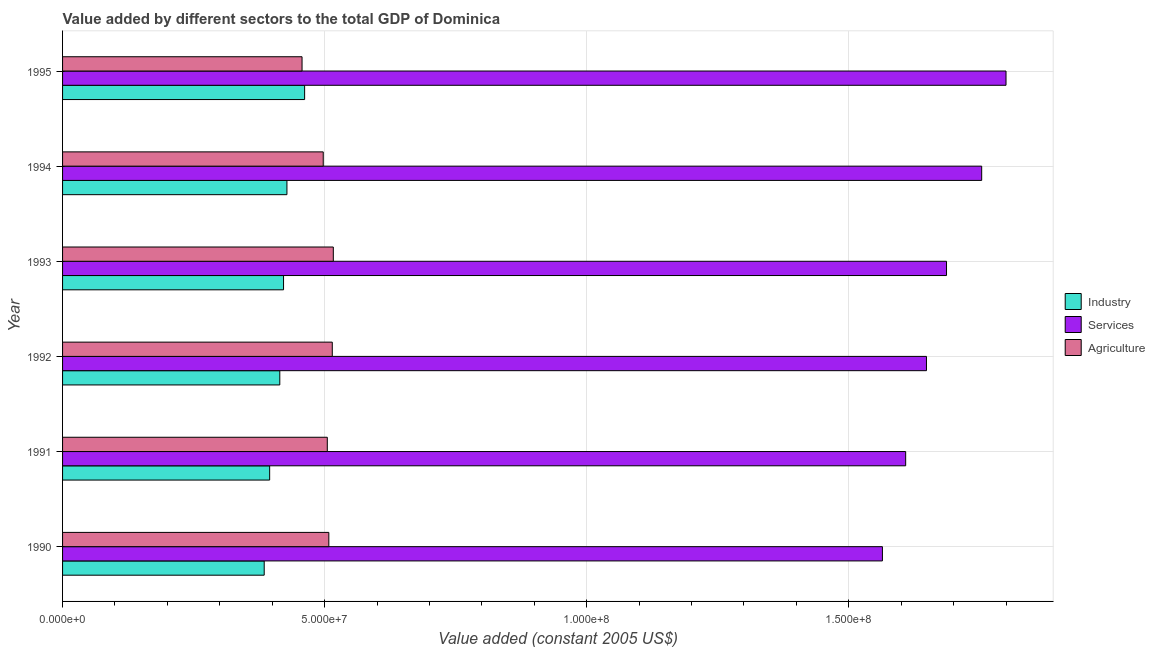How many different coloured bars are there?
Your response must be concise. 3. How many groups of bars are there?
Your answer should be very brief. 6. Are the number of bars per tick equal to the number of legend labels?
Your answer should be very brief. Yes. Are the number of bars on each tick of the Y-axis equal?
Keep it short and to the point. Yes. In how many cases, is the number of bars for a given year not equal to the number of legend labels?
Offer a very short reply. 0. What is the value added by services in 1993?
Provide a short and direct response. 1.69e+08. Across all years, what is the maximum value added by industrial sector?
Offer a terse response. 4.62e+07. Across all years, what is the minimum value added by industrial sector?
Keep it short and to the point. 3.85e+07. In which year was the value added by agricultural sector maximum?
Provide a short and direct response. 1993. In which year was the value added by industrial sector minimum?
Provide a succinct answer. 1990. What is the total value added by industrial sector in the graph?
Provide a short and direct response. 2.51e+08. What is the difference between the value added by industrial sector in 1990 and that in 1995?
Provide a short and direct response. -7.71e+06. What is the difference between the value added by industrial sector in 1992 and the value added by agricultural sector in 1993?
Keep it short and to the point. -1.02e+07. What is the average value added by services per year?
Ensure brevity in your answer.  1.68e+08. In the year 1995, what is the difference between the value added by services and value added by industrial sector?
Offer a terse response. 1.34e+08. In how many years, is the value added by services greater than 40000000 US$?
Your response must be concise. 6. What is the ratio of the value added by industrial sector in 1991 to that in 1994?
Offer a terse response. 0.92. Is the value added by agricultural sector in 1993 less than that in 1994?
Offer a terse response. No. Is the difference between the value added by services in 1993 and 1994 greater than the difference between the value added by agricultural sector in 1993 and 1994?
Your response must be concise. No. What is the difference between the highest and the second highest value added by services?
Your answer should be very brief. 4.64e+06. What is the difference between the highest and the lowest value added by agricultural sector?
Make the answer very short. 5.96e+06. In how many years, is the value added by services greater than the average value added by services taken over all years?
Offer a terse response. 3. Is the sum of the value added by services in 1992 and 1994 greater than the maximum value added by agricultural sector across all years?
Provide a short and direct response. Yes. What does the 3rd bar from the top in 1990 represents?
Offer a terse response. Industry. What does the 3rd bar from the bottom in 1993 represents?
Offer a terse response. Agriculture. How many bars are there?
Provide a succinct answer. 18. Does the graph contain any zero values?
Keep it short and to the point. No. Where does the legend appear in the graph?
Your answer should be compact. Center right. How are the legend labels stacked?
Your answer should be compact. Vertical. What is the title of the graph?
Offer a very short reply. Value added by different sectors to the total GDP of Dominica. Does "Ages 15-64" appear as one of the legend labels in the graph?
Give a very brief answer. No. What is the label or title of the X-axis?
Give a very brief answer. Value added (constant 2005 US$). What is the label or title of the Y-axis?
Ensure brevity in your answer.  Year. What is the Value added (constant 2005 US$) of Industry in 1990?
Offer a terse response. 3.85e+07. What is the Value added (constant 2005 US$) of Services in 1990?
Make the answer very short. 1.56e+08. What is the Value added (constant 2005 US$) of Agriculture in 1990?
Offer a terse response. 5.08e+07. What is the Value added (constant 2005 US$) in Industry in 1991?
Keep it short and to the point. 3.95e+07. What is the Value added (constant 2005 US$) in Services in 1991?
Offer a very short reply. 1.61e+08. What is the Value added (constant 2005 US$) of Agriculture in 1991?
Keep it short and to the point. 5.05e+07. What is the Value added (constant 2005 US$) in Industry in 1992?
Ensure brevity in your answer.  4.14e+07. What is the Value added (constant 2005 US$) in Services in 1992?
Offer a very short reply. 1.65e+08. What is the Value added (constant 2005 US$) of Agriculture in 1992?
Offer a very short reply. 5.15e+07. What is the Value added (constant 2005 US$) in Industry in 1993?
Give a very brief answer. 4.22e+07. What is the Value added (constant 2005 US$) of Services in 1993?
Provide a short and direct response. 1.69e+08. What is the Value added (constant 2005 US$) of Agriculture in 1993?
Offer a terse response. 5.17e+07. What is the Value added (constant 2005 US$) of Industry in 1994?
Give a very brief answer. 4.28e+07. What is the Value added (constant 2005 US$) of Services in 1994?
Provide a short and direct response. 1.75e+08. What is the Value added (constant 2005 US$) in Agriculture in 1994?
Make the answer very short. 4.97e+07. What is the Value added (constant 2005 US$) in Industry in 1995?
Make the answer very short. 4.62e+07. What is the Value added (constant 2005 US$) in Services in 1995?
Make the answer very short. 1.80e+08. What is the Value added (constant 2005 US$) of Agriculture in 1995?
Provide a short and direct response. 4.57e+07. Across all years, what is the maximum Value added (constant 2005 US$) in Industry?
Keep it short and to the point. 4.62e+07. Across all years, what is the maximum Value added (constant 2005 US$) in Services?
Your response must be concise. 1.80e+08. Across all years, what is the maximum Value added (constant 2005 US$) of Agriculture?
Provide a succinct answer. 5.17e+07. Across all years, what is the minimum Value added (constant 2005 US$) in Industry?
Your response must be concise. 3.85e+07. Across all years, what is the minimum Value added (constant 2005 US$) of Services?
Offer a very short reply. 1.56e+08. Across all years, what is the minimum Value added (constant 2005 US$) of Agriculture?
Ensure brevity in your answer.  4.57e+07. What is the total Value added (constant 2005 US$) of Industry in the graph?
Your response must be concise. 2.51e+08. What is the total Value added (constant 2005 US$) in Services in the graph?
Your answer should be compact. 1.01e+09. What is the total Value added (constant 2005 US$) of Agriculture in the graph?
Provide a succinct answer. 3.00e+08. What is the difference between the Value added (constant 2005 US$) in Industry in 1990 and that in 1991?
Offer a terse response. -1.04e+06. What is the difference between the Value added (constant 2005 US$) in Services in 1990 and that in 1991?
Keep it short and to the point. -4.44e+06. What is the difference between the Value added (constant 2005 US$) in Agriculture in 1990 and that in 1991?
Provide a succinct answer. 2.91e+05. What is the difference between the Value added (constant 2005 US$) in Industry in 1990 and that in 1992?
Offer a terse response. -2.97e+06. What is the difference between the Value added (constant 2005 US$) in Services in 1990 and that in 1992?
Make the answer very short. -8.40e+06. What is the difference between the Value added (constant 2005 US$) of Agriculture in 1990 and that in 1992?
Offer a terse response. -6.59e+05. What is the difference between the Value added (constant 2005 US$) in Industry in 1990 and that in 1993?
Your answer should be very brief. -3.69e+06. What is the difference between the Value added (constant 2005 US$) of Services in 1990 and that in 1993?
Keep it short and to the point. -1.22e+07. What is the difference between the Value added (constant 2005 US$) of Agriculture in 1990 and that in 1993?
Offer a very short reply. -8.57e+05. What is the difference between the Value added (constant 2005 US$) of Industry in 1990 and that in 1994?
Your response must be concise. -4.34e+06. What is the difference between the Value added (constant 2005 US$) in Services in 1990 and that in 1994?
Your response must be concise. -1.89e+07. What is the difference between the Value added (constant 2005 US$) in Agriculture in 1990 and that in 1994?
Make the answer very short. 1.07e+06. What is the difference between the Value added (constant 2005 US$) of Industry in 1990 and that in 1995?
Your answer should be very brief. -7.71e+06. What is the difference between the Value added (constant 2005 US$) of Services in 1990 and that in 1995?
Your answer should be very brief. -2.36e+07. What is the difference between the Value added (constant 2005 US$) of Agriculture in 1990 and that in 1995?
Offer a very short reply. 5.11e+06. What is the difference between the Value added (constant 2005 US$) in Industry in 1991 and that in 1992?
Offer a very short reply. -1.93e+06. What is the difference between the Value added (constant 2005 US$) in Services in 1991 and that in 1992?
Keep it short and to the point. -3.97e+06. What is the difference between the Value added (constant 2005 US$) in Agriculture in 1991 and that in 1992?
Your answer should be compact. -9.50e+05. What is the difference between the Value added (constant 2005 US$) of Industry in 1991 and that in 1993?
Offer a terse response. -2.65e+06. What is the difference between the Value added (constant 2005 US$) in Services in 1991 and that in 1993?
Provide a succinct answer. -7.79e+06. What is the difference between the Value added (constant 2005 US$) of Agriculture in 1991 and that in 1993?
Your answer should be very brief. -1.15e+06. What is the difference between the Value added (constant 2005 US$) of Industry in 1991 and that in 1994?
Your answer should be compact. -3.30e+06. What is the difference between the Value added (constant 2005 US$) of Services in 1991 and that in 1994?
Offer a terse response. -1.45e+07. What is the difference between the Value added (constant 2005 US$) in Agriculture in 1991 and that in 1994?
Your response must be concise. 7.74e+05. What is the difference between the Value added (constant 2005 US$) in Industry in 1991 and that in 1995?
Your answer should be compact. -6.67e+06. What is the difference between the Value added (constant 2005 US$) of Services in 1991 and that in 1995?
Your response must be concise. -1.91e+07. What is the difference between the Value added (constant 2005 US$) in Agriculture in 1991 and that in 1995?
Keep it short and to the point. 4.82e+06. What is the difference between the Value added (constant 2005 US$) in Industry in 1992 and that in 1993?
Provide a succinct answer. -7.15e+05. What is the difference between the Value added (constant 2005 US$) in Services in 1992 and that in 1993?
Make the answer very short. -3.82e+06. What is the difference between the Value added (constant 2005 US$) in Agriculture in 1992 and that in 1993?
Offer a very short reply. -1.98e+05. What is the difference between the Value added (constant 2005 US$) in Industry in 1992 and that in 1994?
Give a very brief answer. -1.36e+06. What is the difference between the Value added (constant 2005 US$) in Services in 1992 and that in 1994?
Offer a very short reply. -1.05e+07. What is the difference between the Value added (constant 2005 US$) in Agriculture in 1992 and that in 1994?
Ensure brevity in your answer.  1.72e+06. What is the difference between the Value added (constant 2005 US$) in Industry in 1992 and that in 1995?
Your response must be concise. -4.74e+06. What is the difference between the Value added (constant 2005 US$) in Services in 1992 and that in 1995?
Provide a short and direct response. -1.52e+07. What is the difference between the Value added (constant 2005 US$) in Agriculture in 1992 and that in 1995?
Give a very brief answer. 5.77e+06. What is the difference between the Value added (constant 2005 US$) in Industry in 1993 and that in 1994?
Keep it short and to the point. -6.48e+05. What is the difference between the Value added (constant 2005 US$) of Services in 1993 and that in 1994?
Provide a short and direct response. -6.71e+06. What is the difference between the Value added (constant 2005 US$) of Agriculture in 1993 and that in 1994?
Make the answer very short. 1.92e+06. What is the difference between the Value added (constant 2005 US$) of Industry in 1993 and that in 1995?
Offer a very short reply. -4.02e+06. What is the difference between the Value added (constant 2005 US$) of Services in 1993 and that in 1995?
Make the answer very short. -1.14e+07. What is the difference between the Value added (constant 2005 US$) in Agriculture in 1993 and that in 1995?
Your response must be concise. 5.96e+06. What is the difference between the Value added (constant 2005 US$) in Industry in 1994 and that in 1995?
Offer a very short reply. -3.37e+06. What is the difference between the Value added (constant 2005 US$) of Services in 1994 and that in 1995?
Your response must be concise. -4.64e+06. What is the difference between the Value added (constant 2005 US$) in Agriculture in 1994 and that in 1995?
Your answer should be very brief. 4.04e+06. What is the difference between the Value added (constant 2005 US$) in Industry in 1990 and the Value added (constant 2005 US$) in Services in 1991?
Ensure brevity in your answer.  -1.22e+08. What is the difference between the Value added (constant 2005 US$) in Industry in 1990 and the Value added (constant 2005 US$) in Agriculture in 1991?
Your response must be concise. -1.20e+07. What is the difference between the Value added (constant 2005 US$) of Services in 1990 and the Value added (constant 2005 US$) of Agriculture in 1991?
Keep it short and to the point. 1.06e+08. What is the difference between the Value added (constant 2005 US$) in Industry in 1990 and the Value added (constant 2005 US$) in Services in 1992?
Your answer should be compact. -1.26e+08. What is the difference between the Value added (constant 2005 US$) in Industry in 1990 and the Value added (constant 2005 US$) in Agriculture in 1992?
Keep it short and to the point. -1.30e+07. What is the difference between the Value added (constant 2005 US$) in Services in 1990 and the Value added (constant 2005 US$) in Agriculture in 1992?
Keep it short and to the point. 1.05e+08. What is the difference between the Value added (constant 2005 US$) in Industry in 1990 and the Value added (constant 2005 US$) in Services in 1993?
Offer a terse response. -1.30e+08. What is the difference between the Value added (constant 2005 US$) in Industry in 1990 and the Value added (constant 2005 US$) in Agriculture in 1993?
Make the answer very short. -1.32e+07. What is the difference between the Value added (constant 2005 US$) of Services in 1990 and the Value added (constant 2005 US$) of Agriculture in 1993?
Provide a succinct answer. 1.05e+08. What is the difference between the Value added (constant 2005 US$) in Industry in 1990 and the Value added (constant 2005 US$) in Services in 1994?
Make the answer very short. -1.37e+08. What is the difference between the Value added (constant 2005 US$) of Industry in 1990 and the Value added (constant 2005 US$) of Agriculture in 1994?
Give a very brief answer. -1.13e+07. What is the difference between the Value added (constant 2005 US$) in Services in 1990 and the Value added (constant 2005 US$) in Agriculture in 1994?
Keep it short and to the point. 1.07e+08. What is the difference between the Value added (constant 2005 US$) in Industry in 1990 and the Value added (constant 2005 US$) in Services in 1995?
Your response must be concise. -1.42e+08. What is the difference between the Value added (constant 2005 US$) in Industry in 1990 and the Value added (constant 2005 US$) in Agriculture in 1995?
Ensure brevity in your answer.  -7.22e+06. What is the difference between the Value added (constant 2005 US$) of Services in 1990 and the Value added (constant 2005 US$) of Agriculture in 1995?
Your answer should be compact. 1.11e+08. What is the difference between the Value added (constant 2005 US$) of Industry in 1991 and the Value added (constant 2005 US$) of Services in 1992?
Your response must be concise. -1.25e+08. What is the difference between the Value added (constant 2005 US$) in Industry in 1991 and the Value added (constant 2005 US$) in Agriculture in 1992?
Make the answer very short. -1.19e+07. What is the difference between the Value added (constant 2005 US$) of Services in 1991 and the Value added (constant 2005 US$) of Agriculture in 1992?
Your response must be concise. 1.09e+08. What is the difference between the Value added (constant 2005 US$) of Industry in 1991 and the Value added (constant 2005 US$) of Services in 1993?
Keep it short and to the point. -1.29e+08. What is the difference between the Value added (constant 2005 US$) of Industry in 1991 and the Value added (constant 2005 US$) of Agriculture in 1993?
Your response must be concise. -1.21e+07. What is the difference between the Value added (constant 2005 US$) in Services in 1991 and the Value added (constant 2005 US$) in Agriculture in 1993?
Provide a succinct answer. 1.09e+08. What is the difference between the Value added (constant 2005 US$) in Industry in 1991 and the Value added (constant 2005 US$) in Services in 1994?
Give a very brief answer. -1.36e+08. What is the difference between the Value added (constant 2005 US$) in Industry in 1991 and the Value added (constant 2005 US$) in Agriculture in 1994?
Your answer should be very brief. -1.02e+07. What is the difference between the Value added (constant 2005 US$) in Services in 1991 and the Value added (constant 2005 US$) in Agriculture in 1994?
Give a very brief answer. 1.11e+08. What is the difference between the Value added (constant 2005 US$) in Industry in 1991 and the Value added (constant 2005 US$) in Services in 1995?
Offer a terse response. -1.40e+08. What is the difference between the Value added (constant 2005 US$) of Industry in 1991 and the Value added (constant 2005 US$) of Agriculture in 1995?
Offer a terse response. -6.18e+06. What is the difference between the Value added (constant 2005 US$) in Services in 1991 and the Value added (constant 2005 US$) in Agriculture in 1995?
Ensure brevity in your answer.  1.15e+08. What is the difference between the Value added (constant 2005 US$) in Industry in 1992 and the Value added (constant 2005 US$) in Services in 1993?
Offer a very short reply. -1.27e+08. What is the difference between the Value added (constant 2005 US$) in Industry in 1992 and the Value added (constant 2005 US$) in Agriculture in 1993?
Keep it short and to the point. -1.02e+07. What is the difference between the Value added (constant 2005 US$) in Services in 1992 and the Value added (constant 2005 US$) in Agriculture in 1993?
Your answer should be compact. 1.13e+08. What is the difference between the Value added (constant 2005 US$) of Industry in 1992 and the Value added (constant 2005 US$) of Services in 1994?
Offer a terse response. -1.34e+08. What is the difference between the Value added (constant 2005 US$) of Industry in 1992 and the Value added (constant 2005 US$) of Agriculture in 1994?
Your answer should be very brief. -8.29e+06. What is the difference between the Value added (constant 2005 US$) of Services in 1992 and the Value added (constant 2005 US$) of Agriculture in 1994?
Give a very brief answer. 1.15e+08. What is the difference between the Value added (constant 2005 US$) of Industry in 1992 and the Value added (constant 2005 US$) of Services in 1995?
Provide a short and direct response. -1.39e+08. What is the difference between the Value added (constant 2005 US$) of Industry in 1992 and the Value added (constant 2005 US$) of Agriculture in 1995?
Offer a very short reply. -4.25e+06. What is the difference between the Value added (constant 2005 US$) of Services in 1992 and the Value added (constant 2005 US$) of Agriculture in 1995?
Your response must be concise. 1.19e+08. What is the difference between the Value added (constant 2005 US$) in Industry in 1993 and the Value added (constant 2005 US$) in Services in 1994?
Your answer should be compact. -1.33e+08. What is the difference between the Value added (constant 2005 US$) of Industry in 1993 and the Value added (constant 2005 US$) of Agriculture in 1994?
Your response must be concise. -7.57e+06. What is the difference between the Value added (constant 2005 US$) in Services in 1993 and the Value added (constant 2005 US$) in Agriculture in 1994?
Give a very brief answer. 1.19e+08. What is the difference between the Value added (constant 2005 US$) in Industry in 1993 and the Value added (constant 2005 US$) in Services in 1995?
Offer a very short reply. -1.38e+08. What is the difference between the Value added (constant 2005 US$) in Industry in 1993 and the Value added (constant 2005 US$) in Agriculture in 1995?
Your answer should be compact. -3.53e+06. What is the difference between the Value added (constant 2005 US$) in Services in 1993 and the Value added (constant 2005 US$) in Agriculture in 1995?
Offer a terse response. 1.23e+08. What is the difference between the Value added (constant 2005 US$) in Industry in 1994 and the Value added (constant 2005 US$) in Services in 1995?
Offer a very short reply. -1.37e+08. What is the difference between the Value added (constant 2005 US$) in Industry in 1994 and the Value added (constant 2005 US$) in Agriculture in 1995?
Offer a terse response. -2.88e+06. What is the difference between the Value added (constant 2005 US$) of Services in 1994 and the Value added (constant 2005 US$) of Agriculture in 1995?
Offer a terse response. 1.30e+08. What is the average Value added (constant 2005 US$) in Industry per year?
Your response must be concise. 4.18e+07. What is the average Value added (constant 2005 US$) in Services per year?
Give a very brief answer. 1.68e+08. What is the average Value added (constant 2005 US$) of Agriculture per year?
Offer a very short reply. 5.00e+07. In the year 1990, what is the difference between the Value added (constant 2005 US$) in Industry and Value added (constant 2005 US$) in Services?
Ensure brevity in your answer.  -1.18e+08. In the year 1990, what is the difference between the Value added (constant 2005 US$) of Industry and Value added (constant 2005 US$) of Agriculture?
Your answer should be compact. -1.23e+07. In the year 1990, what is the difference between the Value added (constant 2005 US$) in Services and Value added (constant 2005 US$) in Agriculture?
Offer a very short reply. 1.06e+08. In the year 1991, what is the difference between the Value added (constant 2005 US$) in Industry and Value added (constant 2005 US$) in Services?
Offer a very short reply. -1.21e+08. In the year 1991, what is the difference between the Value added (constant 2005 US$) of Industry and Value added (constant 2005 US$) of Agriculture?
Keep it short and to the point. -1.10e+07. In the year 1991, what is the difference between the Value added (constant 2005 US$) of Services and Value added (constant 2005 US$) of Agriculture?
Give a very brief answer. 1.10e+08. In the year 1992, what is the difference between the Value added (constant 2005 US$) of Industry and Value added (constant 2005 US$) of Services?
Provide a succinct answer. -1.23e+08. In the year 1992, what is the difference between the Value added (constant 2005 US$) in Industry and Value added (constant 2005 US$) in Agriculture?
Offer a terse response. -1.00e+07. In the year 1992, what is the difference between the Value added (constant 2005 US$) in Services and Value added (constant 2005 US$) in Agriculture?
Provide a succinct answer. 1.13e+08. In the year 1993, what is the difference between the Value added (constant 2005 US$) in Industry and Value added (constant 2005 US$) in Services?
Make the answer very short. -1.26e+08. In the year 1993, what is the difference between the Value added (constant 2005 US$) in Industry and Value added (constant 2005 US$) in Agriculture?
Offer a very short reply. -9.50e+06. In the year 1993, what is the difference between the Value added (constant 2005 US$) of Services and Value added (constant 2005 US$) of Agriculture?
Offer a terse response. 1.17e+08. In the year 1994, what is the difference between the Value added (constant 2005 US$) in Industry and Value added (constant 2005 US$) in Services?
Give a very brief answer. -1.33e+08. In the year 1994, what is the difference between the Value added (constant 2005 US$) of Industry and Value added (constant 2005 US$) of Agriculture?
Offer a terse response. -6.93e+06. In the year 1994, what is the difference between the Value added (constant 2005 US$) in Services and Value added (constant 2005 US$) in Agriculture?
Ensure brevity in your answer.  1.26e+08. In the year 1995, what is the difference between the Value added (constant 2005 US$) of Industry and Value added (constant 2005 US$) of Services?
Provide a succinct answer. -1.34e+08. In the year 1995, what is the difference between the Value added (constant 2005 US$) of Industry and Value added (constant 2005 US$) of Agriculture?
Your answer should be compact. 4.92e+05. In the year 1995, what is the difference between the Value added (constant 2005 US$) of Services and Value added (constant 2005 US$) of Agriculture?
Offer a very short reply. 1.34e+08. What is the ratio of the Value added (constant 2005 US$) of Industry in 1990 to that in 1991?
Give a very brief answer. 0.97. What is the ratio of the Value added (constant 2005 US$) in Services in 1990 to that in 1991?
Your response must be concise. 0.97. What is the ratio of the Value added (constant 2005 US$) in Industry in 1990 to that in 1992?
Provide a succinct answer. 0.93. What is the ratio of the Value added (constant 2005 US$) of Services in 1990 to that in 1992?
Provide a short and direct response. 0.95. What is the ratio of the Value added (constant 2005 US$) in Agriculture in 1990 to that in 1992?
Give a very brief answer. 0.99. What is the ratio of the Value added (constant 2005 US$) of Industry in 1990 to that in 1993?
Offer a terse response. 0.91. What is the ratio of the Value added (constant 2005 US$) in Services in 1990 to that in 1993?
Provide a short and direct response. 0.93. What is the ratio of the Value added (constant 2005 US$) of Agriculture in 1990 to that in 1993?
Make the answer very short. 0.98. What is the ratio of the Value added (constant 2005 US$) in Industry in 1990 to that in 1994?
Give a very brief answer. 0.9. What is the ratio of the Value added (constant 2005 US$) in Services in 1990 to that in 1994?
Ensure brevity in your answer.  0.89. What is the ratio of the Value added (constant 2005 US$) in Agriculture in 1990 to that in 1994?
Offer a terse response. 1.02. What is the ratio of the Value added (constant 2005 US$) of Industry in 1990 to that in 1995?
Keep it short and to the point. 0.83. What is the ratio of the Value added (constant 2005 US$) of Services in 1990 to that in 1995?
Your answer should be compact. 0.87. What is the ratio of the Value added (constant 2005 US$) in Agriculture in 1990 to that in 1995?
Make the answer very short. 1.11. What is the ratio of the Value added (constant 2005 US$) in Industry in 1991 to that in 1992?
Give a very brief answer. 0.95. What is the ratio of the Value added (constant 2005 US$) in Services in 1991 to that in 1992?
Provide a short and direct response. 0.98. What is the ratio of the Value added (constant 2005 US$) in Agriculture in 1991 to that in 1992?
Ensure brevity in your answer.  0.98. What is the ratio of the Value added (constant 2005 US$) of Industry in 1991 to that in 1993?
Offer a very short reply. 0.94. What is the ratio of the Value added (constant 2005 US$) in Services in 1991 to that in 1993?
Provide a short and direct response. 0.95. What is the ratio of the Value added (constant 2005 US$) in Agriculture in 1991 to that in 1993?
Your response must be concise. 0.98. What is the ratio of the Value added (constant 2005 US$) of Industry in 1991 to that in 1994?
Make the answer very short. 0.92. What is the ratio of the Value added (constant 2005 US$) of Services in 1991 to that in 1994?
Make the answer very short. 0.92. What is the ratio of the Value added (constant 2005 US$) in Agriculture in 1991 to that in 1994?
Your response must be concise. 1.02. What is the ratio of the Value added (constant 2005 US$) in Industry in 1991 to that in 1995?
Keep it short and to the point. 0.86. What is the ratio of the Value added (constant 2005 US$) of Services in 1991 to that in 1995?
Your answer should be compact. 0.89. What is the ratio of the Value added (constant 2005 US$) in Agriculture in 1991 to that in 1995?
Offer a very short reply. 1.11. What is the ratio of the Value added (constant 2005 US$) in Industry in 1992 to that in 1993?
Offer a terse response. 0.98. What is the ratio of the Value added (constant 2005 US$) of Services in 1992 to that in 1993?
Provide a succinct answer. 0.98. What is the ratio of the Value added (constant 2005 US$) of Industry in 1992 to that in 1994?
Your answer should be very brief. 0.97. What is the ratio of the Value added (constant 2005 US$) of Services in 1992 to that in 1994?
Make the answer very short. 0.94. What is the ratio of the Value added (constant 2005 US$) of Agriculture in 1992 to that in 1994?
Your answer should be very brief. 1.03. What is the ratio of the Value added (constant 2005 US$) in Industry in 1992 to that in 1995?
Make the answer very short. 0.9. What is the ratio of the Value added (constant 2005 US$) of Services in 1992 to that in 1995?
Provide a succinct answer. 0.92. What is the ratio of the Value added (constant 2005 US$) of Agriculture in 1992 to that in 1995?
Offer a terse response. 1.13. What is the ratio of the Value added (constant 2005 US$) in Industry in 1993 to that in 1994?
Your answer should be compact. 0.98. What is the ratio of the Value added (constant 2005 US$) of Services in 1993 to that in 1994?
Keep it short and to the point. 0.96. What is the ratio of the Value added (constant 2005 US$) in Agriculture in 1993 to that in 1994?
Offer a very short reply. 1.04. What is the ratio of the Value added (constant 2005 US$) in Industry in 1993 to that in 1995?
Your answer should be compact. 0.91. What is the ratio of the Value added (constant 2005 US$) in Services in 1993 to that in 1995?
Your response must be concise. 0.94. What is the ratio of the Value added (constant 2005 US$) in Agriculture in 1993 to that in 1995?
Provide a short and direct response. 1.13. What is the ratio of the Value added (constant 2005 US$) in Industry in 1994 to that in 1995?
Provide a short and direct response. 0.93. What is the ratio of the Value added (constant 2005 US$) in Services in 1994 to that in 1995?
Give a very brief answer. 0.97. What is the ratio of the Value added (constant 2005 US$) of Agriculture in 1994 to that in 1995?
Keep it short and to the point. 1.09. What is the difference between the highest and the second highest Value added (constant 2005 US$) in Industry?
Your answer should be very brief. 3.37e+06. What is the difference between the highest and the second highest Value added (constant 2005 US$) of Services?
Give a very brief answer. 4.64e+06. What is the difference between the highest and the second highest Value added (constant 2005 US$) in Agriculture?
Your answer should be compact. 1.98e+05. What is the difference between the highest and the lowest Value added (constant 2005 US$) of Industry?
Make the answer very short. 7.71e+06. What is the difference between the highest and the lowest Value added (constant 2005 US$) in Services?
Provide a short and direct response. 2.36e+07. What is the difference between the highest and the lowest Value added (constant 2005 US$) of Agriculture?
Provide a succinct answer. 5.96e+06. 